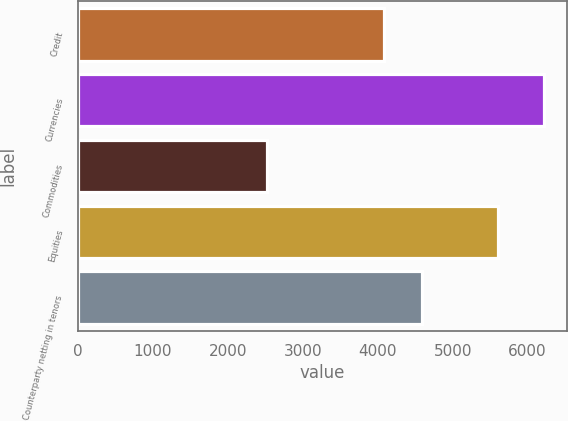Convert chart to OTSL. <chart><loc_0><loc_0><loc_500><loc_500><bar_chart><fcel>Credit<fcel>Currencies<fcel>Commodities<fcel>Equities<fcel>Counterparty netting in tenors<nl><fcel>4079<fcel>6219<fcel>2526<fcel>5607<fcel>4594<nl></chart> 